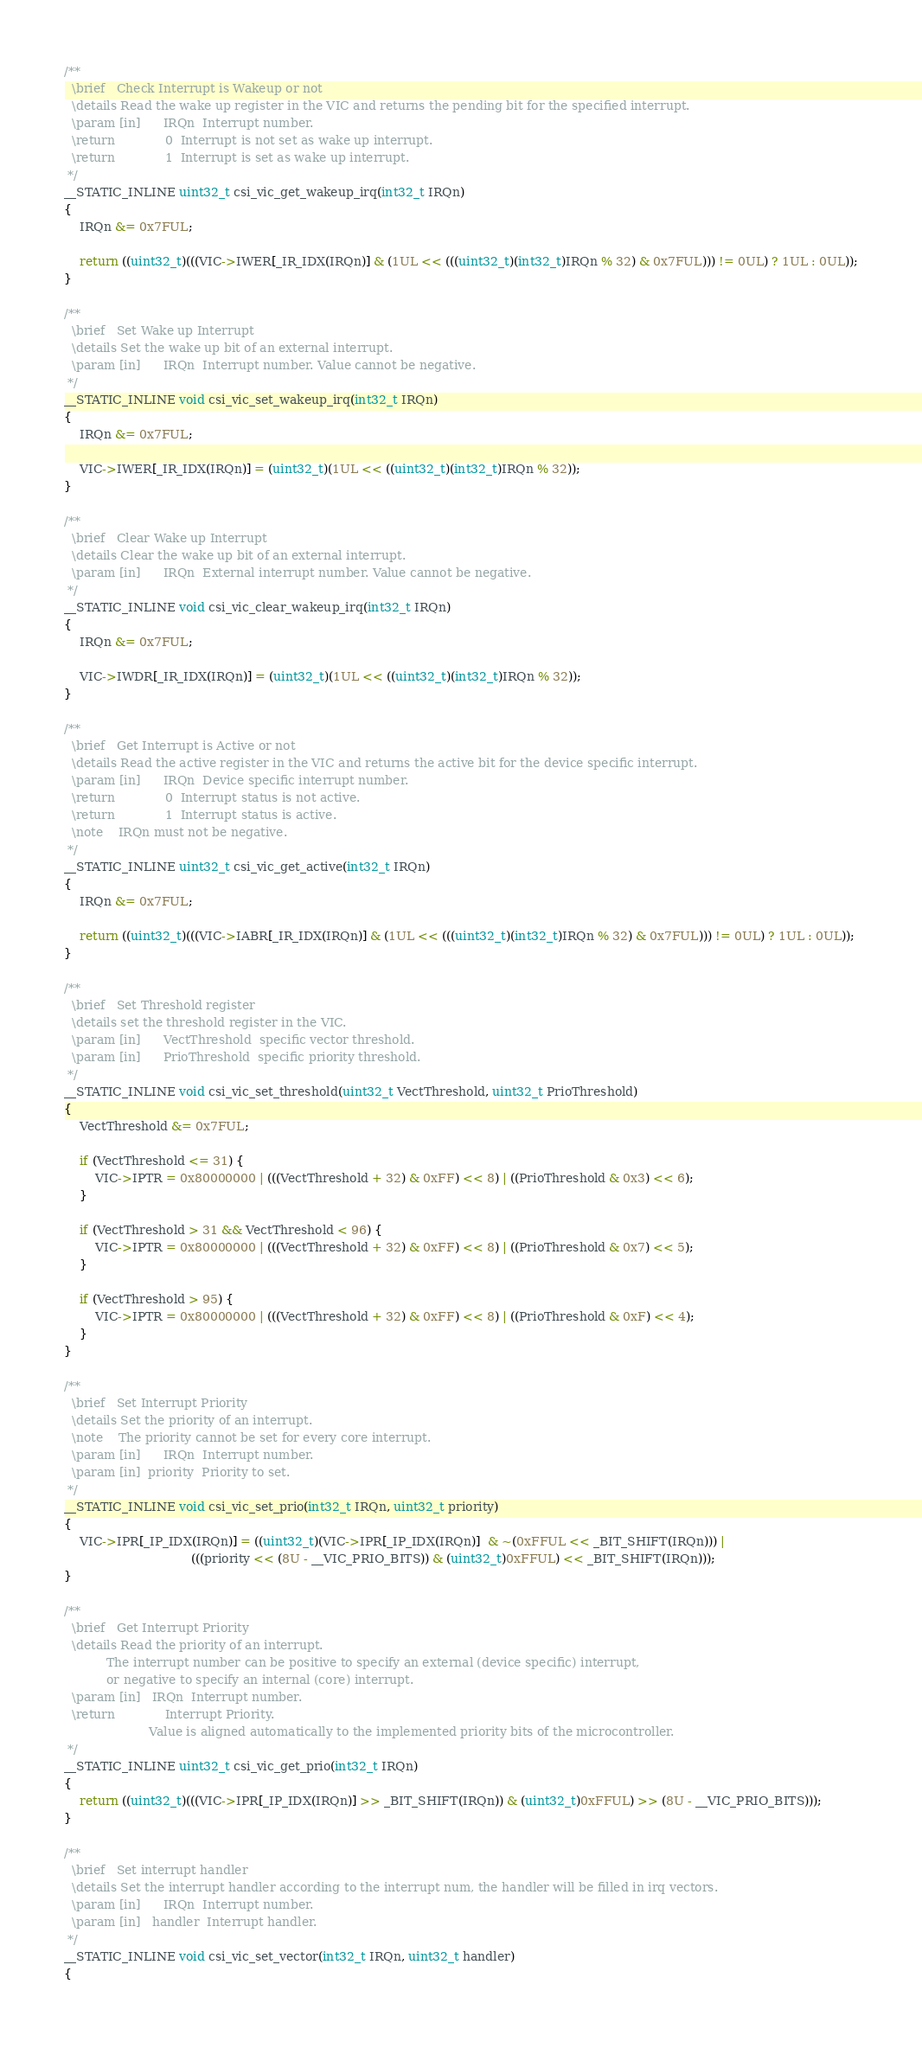Convert code to text. <code><loc_0><loc_0><loc_500><loc_500><_C_>/**
  \brief   Check Interrupt is Wakeup or not
  \details Read the wake up register in the VIC and returns the pending bit for the specified interrupt.
  \param [in]      IRQn  Interrupt number.
  \return             0  Interrupt is not set as wake up interrupt.
  \return             1  Interrupt is set as wake up interrupt.
 */
__STATIC_INLINE uint32_t csi_vic_get_wakeup_irq(int32_t IRQn)
{
    IRQn &= 0x7FUL;

    return ((uint32_t)(((VIC->IWER[_IR_IDX(IRQn)] & (1UL << (((uint32_t)(int32_t)IRQn % 32) & 0x7FUL))) != 0UL) ? 1UL : 0UL));
}

/**
  \brief   Set Wake up Interrupt
  \details Set the wake up bit of an external interrupt.
  \param [in]      IRQn  Interrupt number. Value cannot be negative.
 */
__STATIC_INLINE void csi_vic_set_wakeup_irq(int32_t IRQn)
{
    IRQn &= 0x7FUL;

    VIC->IWER[_IR_IDX(IRQn)] = (uint32_t)(1UL << ((uint32_t)(int32_t)IRQn % 32));
}

/**
  \brief   Clear Wake up Interrupt
  \details Clear the wake up bit of an external interrupt.
  \param [in]      IRQn  External interrupt number. Value cannot be negative.
 */
__STATIC_INLINE void csi_vic_clear_wakeup_irq(int32_t IRQn)
{
    IRQn &= 0x7FUL;

    VIC->IWDR[_IR_IDX(IRQn)] = (uint32_t)(1UL << ((uint32_t)(int32_t)IRQn % 32));
}

/**
  \brief   Get Interrupt is Active or not
  \details Read the active register in the VIC and returns the active bit for the device specific interrupt.
  \param [in]      IRQn  Device specific interrupt number.
  \return             0  Interrupt status is not active.
  \return             1  Interrupt status is active.
  \note    IRQn must not be negative.
 */
__STATIC_INLINE uint32_t csi_vic_get_active(int32_t IRQn)
{
    IRQn &= 0x7FUL;

    return ((uint32_t)(((VIC->IABR[_IR_IDX(IRQn)] & (1UL << (((uint32_t)(int32_t)IRQn % 32) & 0x7FUL))) != 0UL) ? 1UL : 0UL));
}

/**
  \brief   Set Threshold register
  \details set the threshold register in the VIC.
  \param [in]      VectThreshold  specific vector threshold.
  \param [in]      PrioThreshold  specific priority threshold.
 */
__STATIC_INLINE void csi_vic_set_threshold(uint32_t VectThreshold, uint32_t PrioThreshold)
{
    VectThreshold &= 0x7FUL;

    if (VectThreshold <= 31) {
        VIC->IPTR = 0x80000000 | (((VectThreshold + 32) & 0xFF) << 8) | ((PrioThreshold & 0x3) << 6);
    }

    if (VectThreshold > 31 && VectThreshold < 96) {
        VIC->IPTR = 0x80000000 | (((VectThreshold + 32) & 0xFF) << 8) | ((PrioThreshold & 0x7) << 5);
    }

    if (VectThreshold > 95) {
        VIC->IPTR = 0x80000000 | (((VectThreshold + 32) & 0xFF) << 8) | ((PrioThreshold & 0xF) << 4);
    }
}

/**
  \brief   Set Interrupt Priority
  \details Set the priority of an interrupt.
  \note    The priority cannot be set for every core interrupt.
  \param [in]      IRQn  Interrupt number.
  \param [in]  priority  Priority to set.
 */
__STATIC_INLINE void csi_vic_set_prio(int32_t IRQn, uint32_t priority)
{
    VIC->IPR[_IP_IDX(IRQn)] = ((uint32_t)(VIC->IPR[_IP_IDX(IRQn)]  & ~(0xFFUL << _BIT_SHIFT(IRQn))) |
                                 (((priority << (8U - __VIC_PRIO_BITS)) & (uint32_t)0xFFUL) << _BIT_SHIFT(IRQn)));
}

/**
  \brief   Get Interrupt Priority
  \details Read the priority of an interrupt.
           The interrupt number can be positive to specify an external (device specific) interrupt,
           or negative to specify an internal (core) interrupt.
  \param [in]   IRQn  Interrupt number.
  \return             Interrupt Priority.
                      Value is aligned automatically to the implemented priority bits of the microcontroller.
 */
__STATIC_INLINE uint32_t csi_vic_get_prio(int32_t IRQn)
{
    return ((uint32_t)(((VIC->IPR[_IP_IDX(IRQn)] >> _BIT_SHIFT(IRQn)) & (uint32_t)0xFFUL) >> (8U - __VIC_PRIO_BITS)));
}

/**
  \brief   Set interrupt handler
  \details Set the interrupt handler according to the interrupt num, the handler will be filled in irq vectors.
  \param [in]      IRQn  Interrupt number.
  \param [in]   handler  Interrupt handler.
 */
__STATIC_INLINE void csi_vic_set_vector(int32_t IRQn, uint32_t handler)
{</code> 